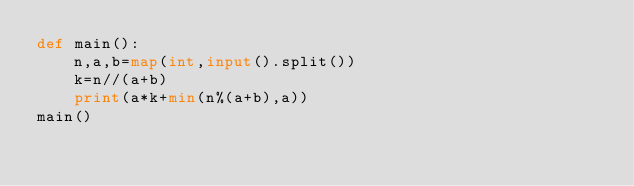<code> <loc_0><loc_0><loc_500><loc_500><_Python_>def main():
    n,a,b=map(int,input().split())
    k=n//(a+b)
    print(a*k+min(n%(a+b),a))
main()</code> 